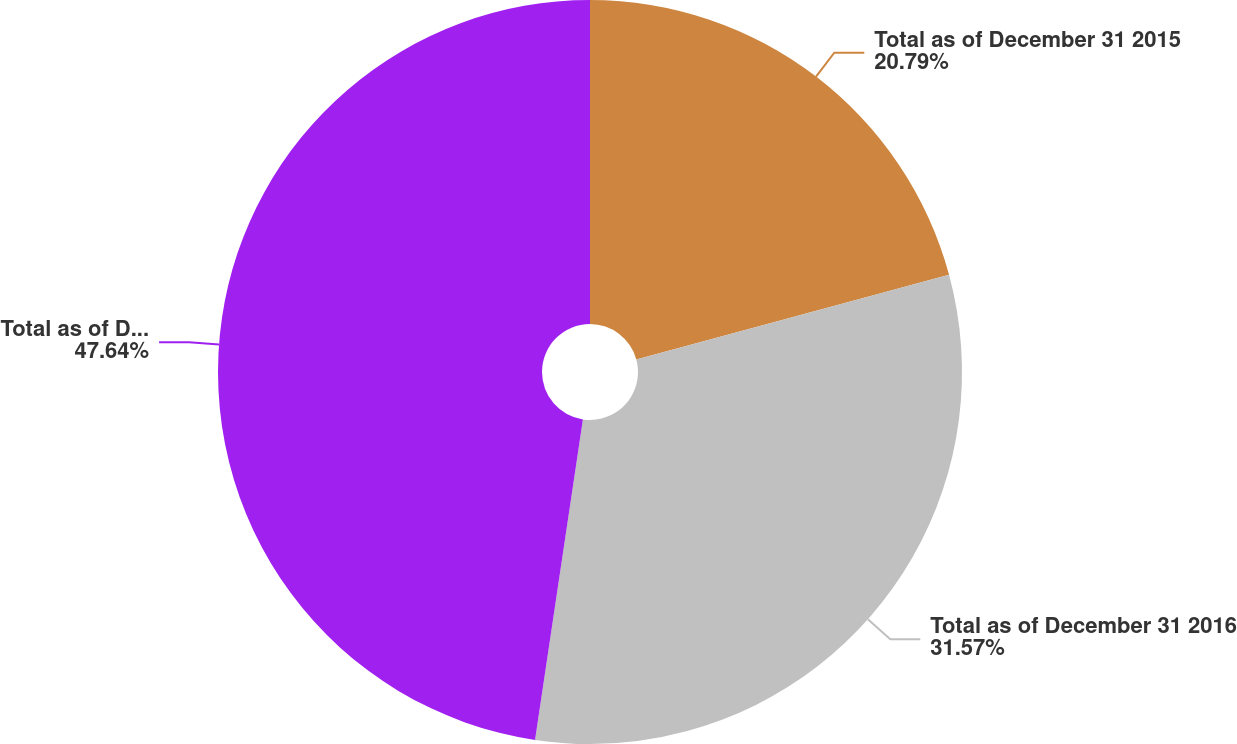Convert chart to OTSL. <chart><loc_0><loc_0><loc_500><loc_500><pie_chart><fcel>Total as of December 31 2015<fcel>Total as of December 31 2016<fcel>Total as of December 31 2017<nl><fcel>20.79%<fcel>31.57%<fcel>47.64%<nl></chart> 